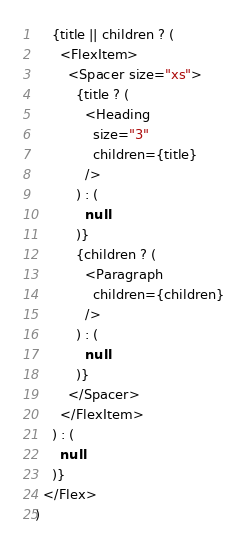Convert code to text. <code><loc_0><loc_0><loc_500><loc_500><_TypeScript_>    {title || children ? (
      <FlexItem>
        <Spacer size="xs">
          {title ? (
            <Heading
              size="3"
              children={title}
            />
          ) : (
            null
          )}
          {children ? (
            <Paragraph
              children={children}
            />
          ) : (
            null
          )}
        </Spacer>
      </FlexItem>
    ) : (
      null
    )}
  </Flex>
)
</code> 